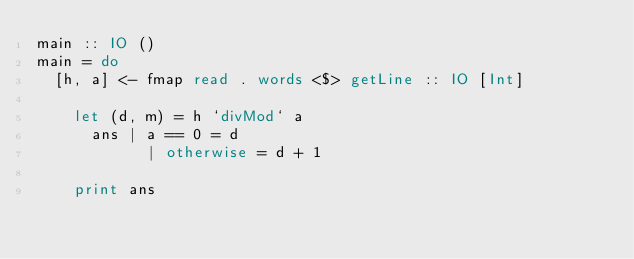Convert code to text. <code><loc_0><loc_0><loc_500><loc_500><_Haskell_>main :: IO ()
main = do
	[h, a] <- fmap read . words <$> getLine :: IO [Int]
    
    let (d, m) = h `divMod` a
    	ans | a == 0 = d
            | otherwise = d + 1
    
    print ans</code> 